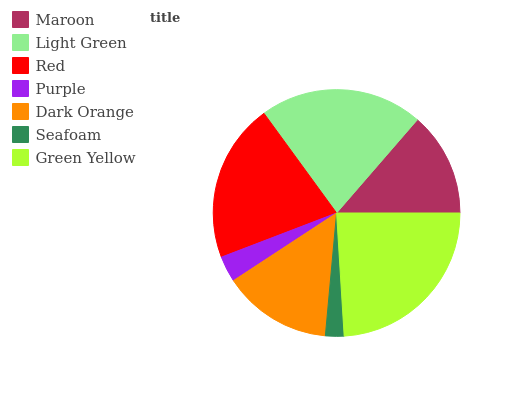Is Seafoam the minimum?
Answer yes or no. Yes. Is Green Yellow the maximum?
Answer yes or no. Yes. Is Light Green the minimum?
Answer yes or no. No. Is Light Green the maximum?
Answer yes or no. No. Is Light Green greater than Maroon?
Answer yes or no. Yes. Is Maroon less than Light Green?
Answer yes or no. Yes. Is Maroon greater than Light Green?
Answer yes or no. No. Is Light Green less than Maroon?
Answer yes or no. No. Is Dark Orange the high median?
Answer yes or no. Yes. Is Dark Orange the low median?
Answer yes or no. Yes. Is Purple the high median?
Answer yes or no. No. Is Green Yellow the low median?
Answer yes or no. No. 